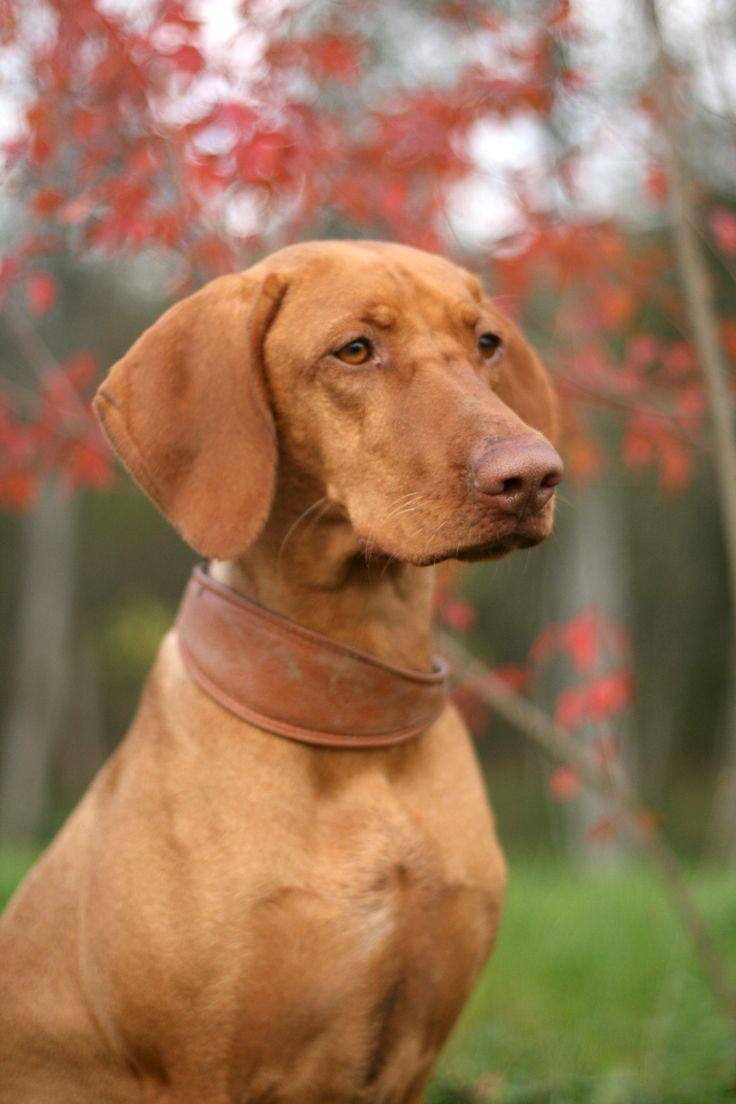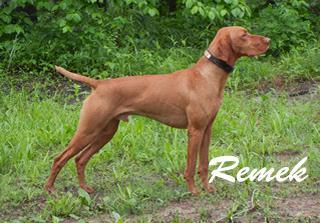The first image is the image on the left, the second image is the image on the right. Considering the images on both sides, is "The dog in one of the images is standing in the grass." valid? Answer yes or no. Yes. The first image is the image on the left, the second image is the image on the right. Considering the images on both sides, is "Each image contains one red-orange adult dog, and one image shows a dog in a black collar standing on all fours in the grass facing rightward." valid? Answer yes or no. Yes. 